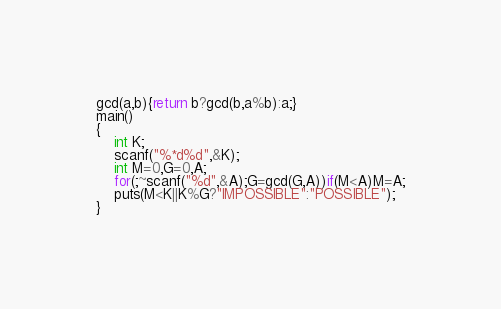<code> <loc_0><loc_0><loc_500><loc_500><_C_>gcd(a,b){return b?gcd(b,a%b):a;}
main()
{
	int K;
	scanf("%*d%d",&K);
	int M=0,G=0,A;
	for(;~scanf("%d",&A);G=gcd(G,A))if(M<A)M=A;
	puts(M<K||K%G?"IMPOSSIBLE":"POSSIBLE");
}
</code> 